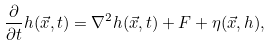<formula> <loc_0><loc_0><loc_500><loc_500>\frac { \partial } { \partial t } h ( \vec { x } , t ) = \nabla ^ { 2 } h ( \vec { x } , t ) + F + \eta ( \vec { x } , h ) ,</formula> 